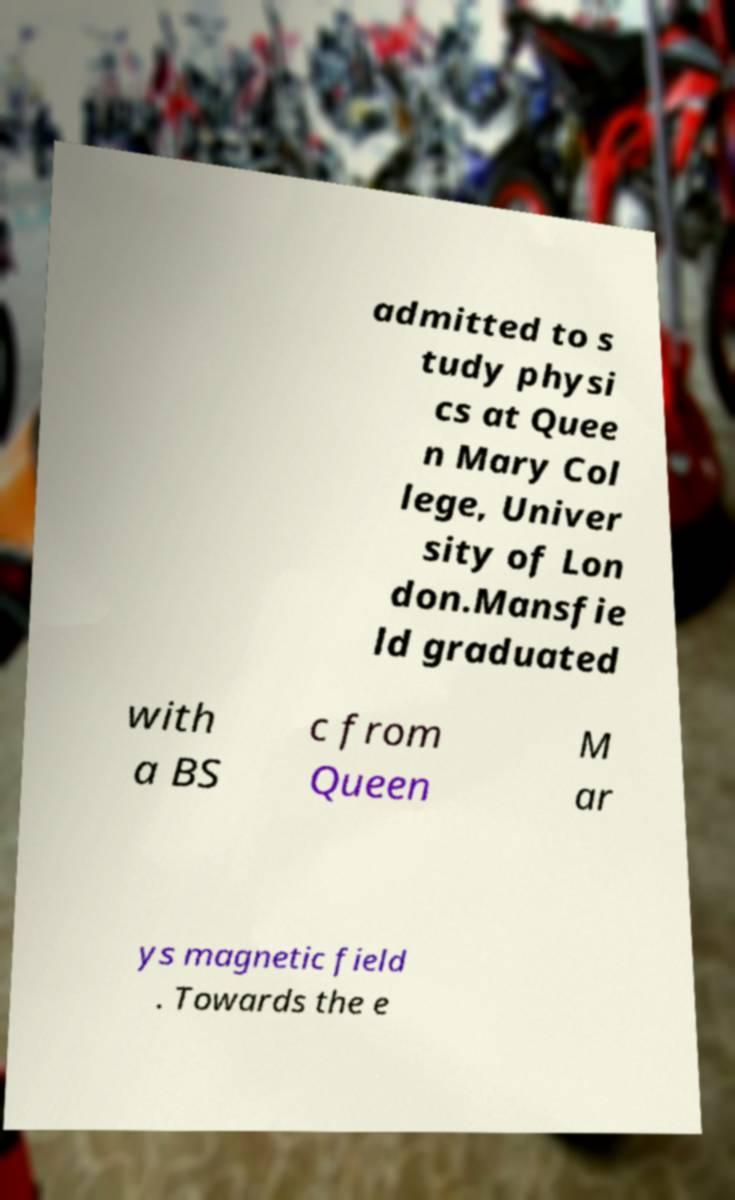I need the written content from this picture converted into text. Can you do that? admitted to s tudy physi cs at Quee n Mary Col lege, Univer sity of Lon don.Mansfie ld graduated with a BS c from Queen M ar ys magnetic field . Towards the e 